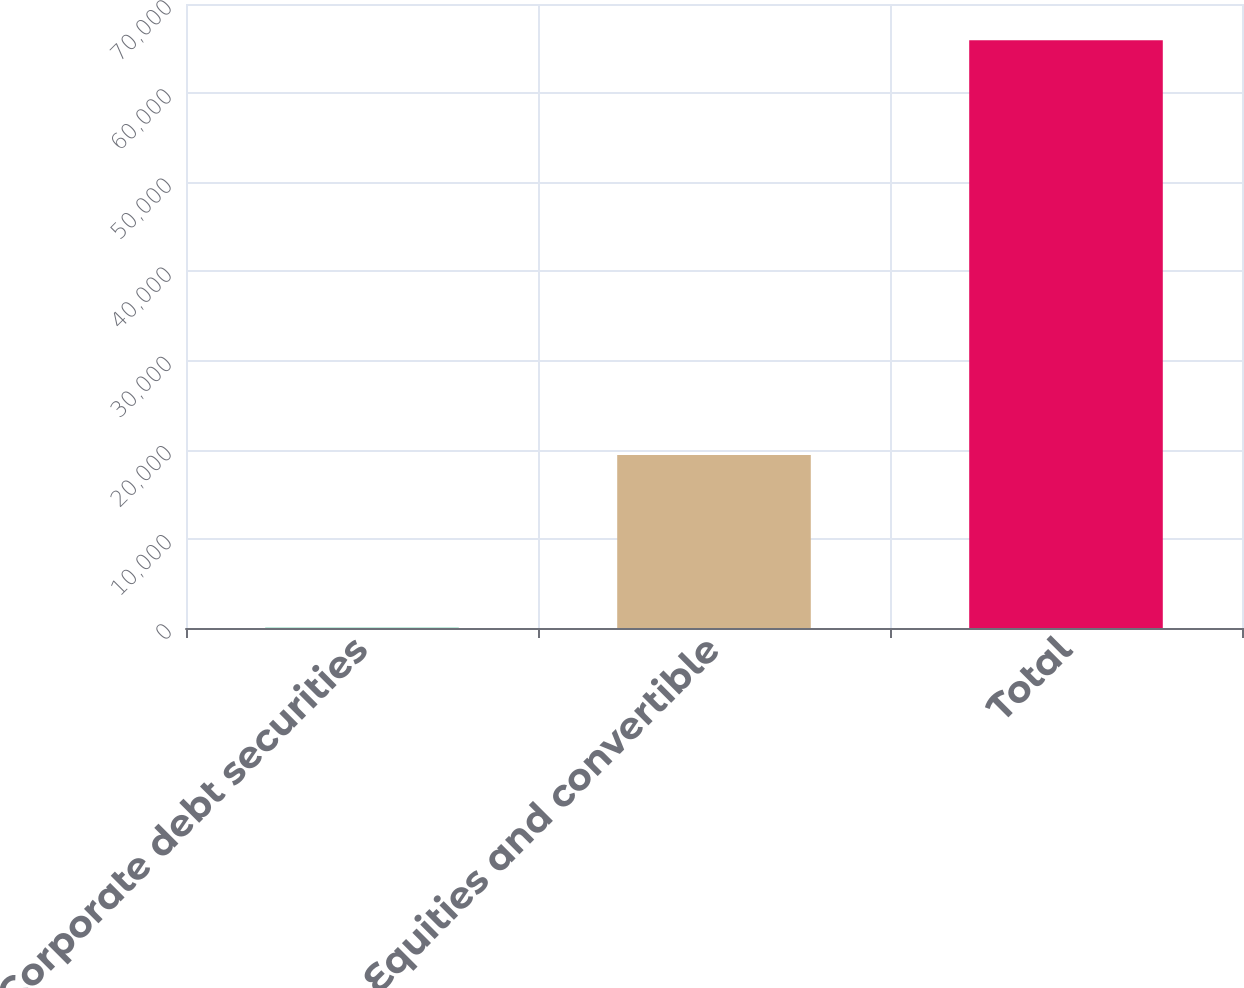Convert chart. <chart><loc_0><loc_0><loc_500><loc_500><bar_chart><fcel>Corporate debt securities<fcel>Equities and convertible<fcel>Total<nl><fcel>28<fcel>19416<fcel>65930<nl></chart> 